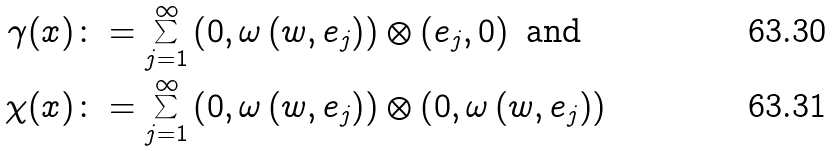Convert formula to latex. <formula><loc_0><loc_0><loc_500><loc_500>\gamma ( x ) & \colon = \sum _ { j = 1 } ^ { \infty } \left ( 0 , \omega \left ( w , e _ { j } \right ) \right ) \otimes \left ( e _ { j } , 0 \right ) \text { and} \\ \chi ( x ) & \colon = \sum _ { j = 1 } ^ { \infty } \left ( 0 , \omega \left ( w , e _ { j } \right ) \right ) \otimes \left ( 0 , \omega \left ( w , e _ { j } \right ) \right )</formula> 